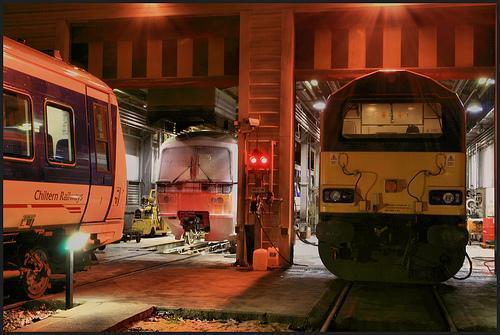How many train cars are pictured?
Give a very brief answer. 3. How many lights are red?
Give a very brief answer. 2. 